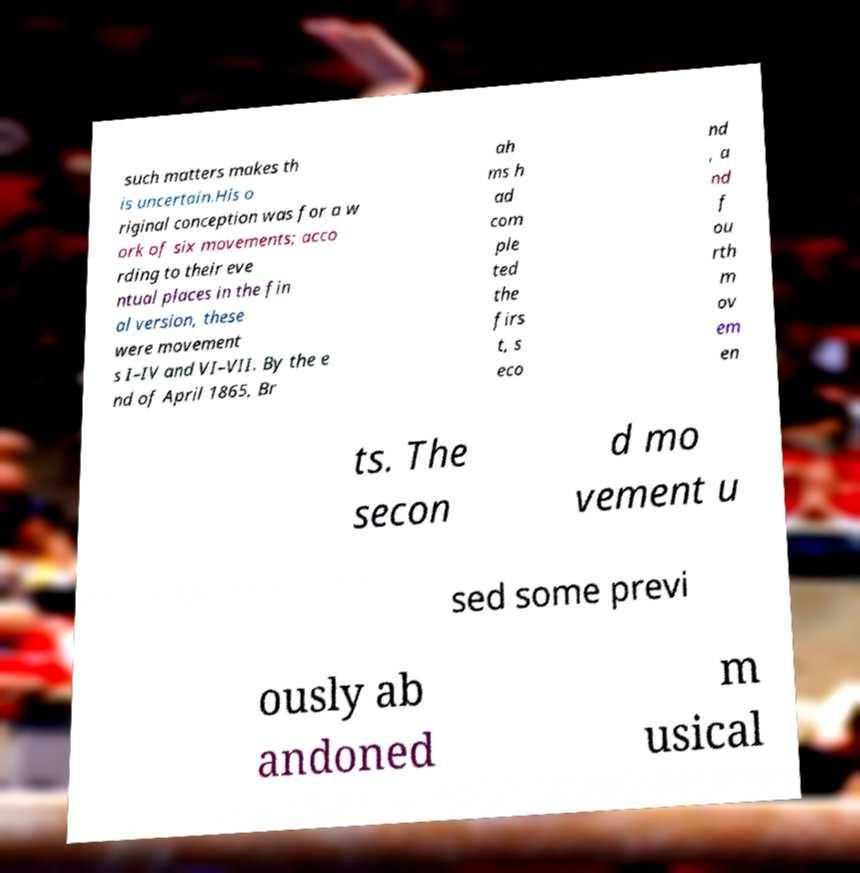I need the written content from this picture converted into text. Can you do that? such matters makes th is uncertain.His o riginal conception was for a w ork of six movements; acco rding to their eve ntual places in the fin al version, these were movement s I–IV and VI–VII. By the e nd of April 1865, Br ah ms h ad com ple ted the firs t, s eco nd , a nd f ou rth m ov em en ts. The secon d mo vement u sed some previ ously ab andoned m usical 